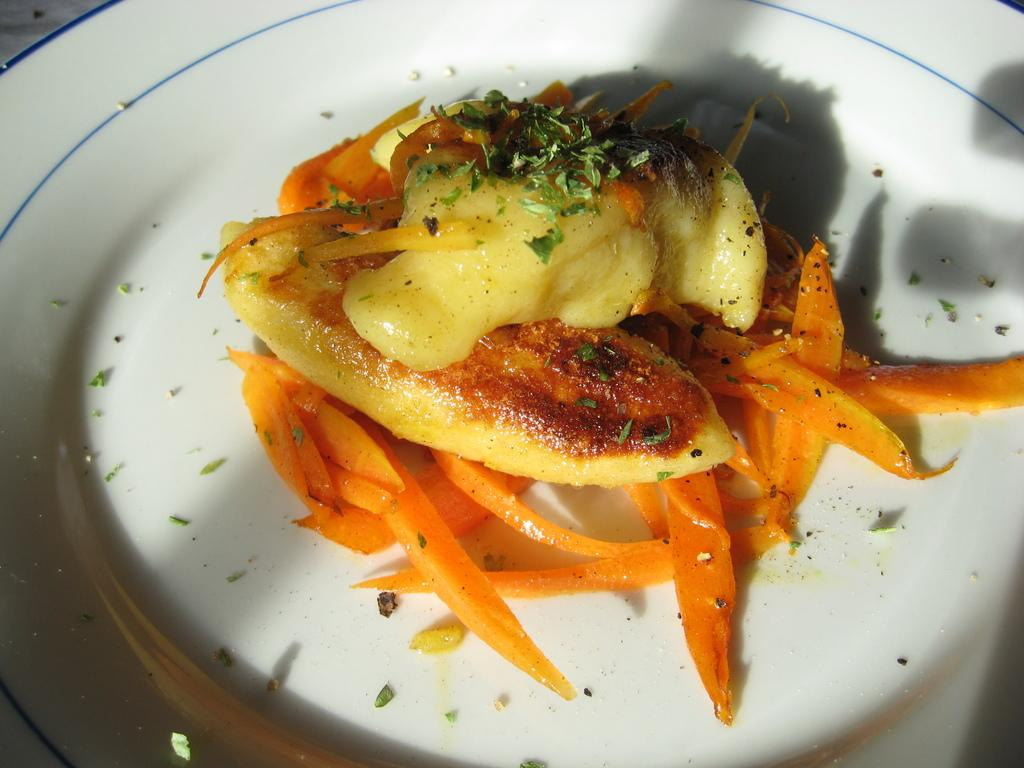What is present on the plate in the image? There are food items on a plate in the image. What type of pipe can be seen in the image? There is no pipe present in the image; it features a plate with food items. Where is the library located in the image? There is no library present in the image; it features a plate with food items. 